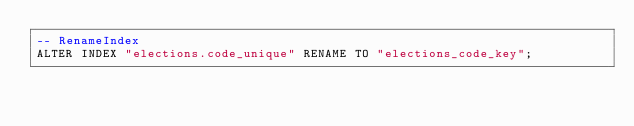<code> <loc_0><loc_0><loc_500><loc_500><_SQL_>-- RenameIndex
ALTER INDEX "elections.code_unique" RENAME TO "elections_code_key";
</code> 